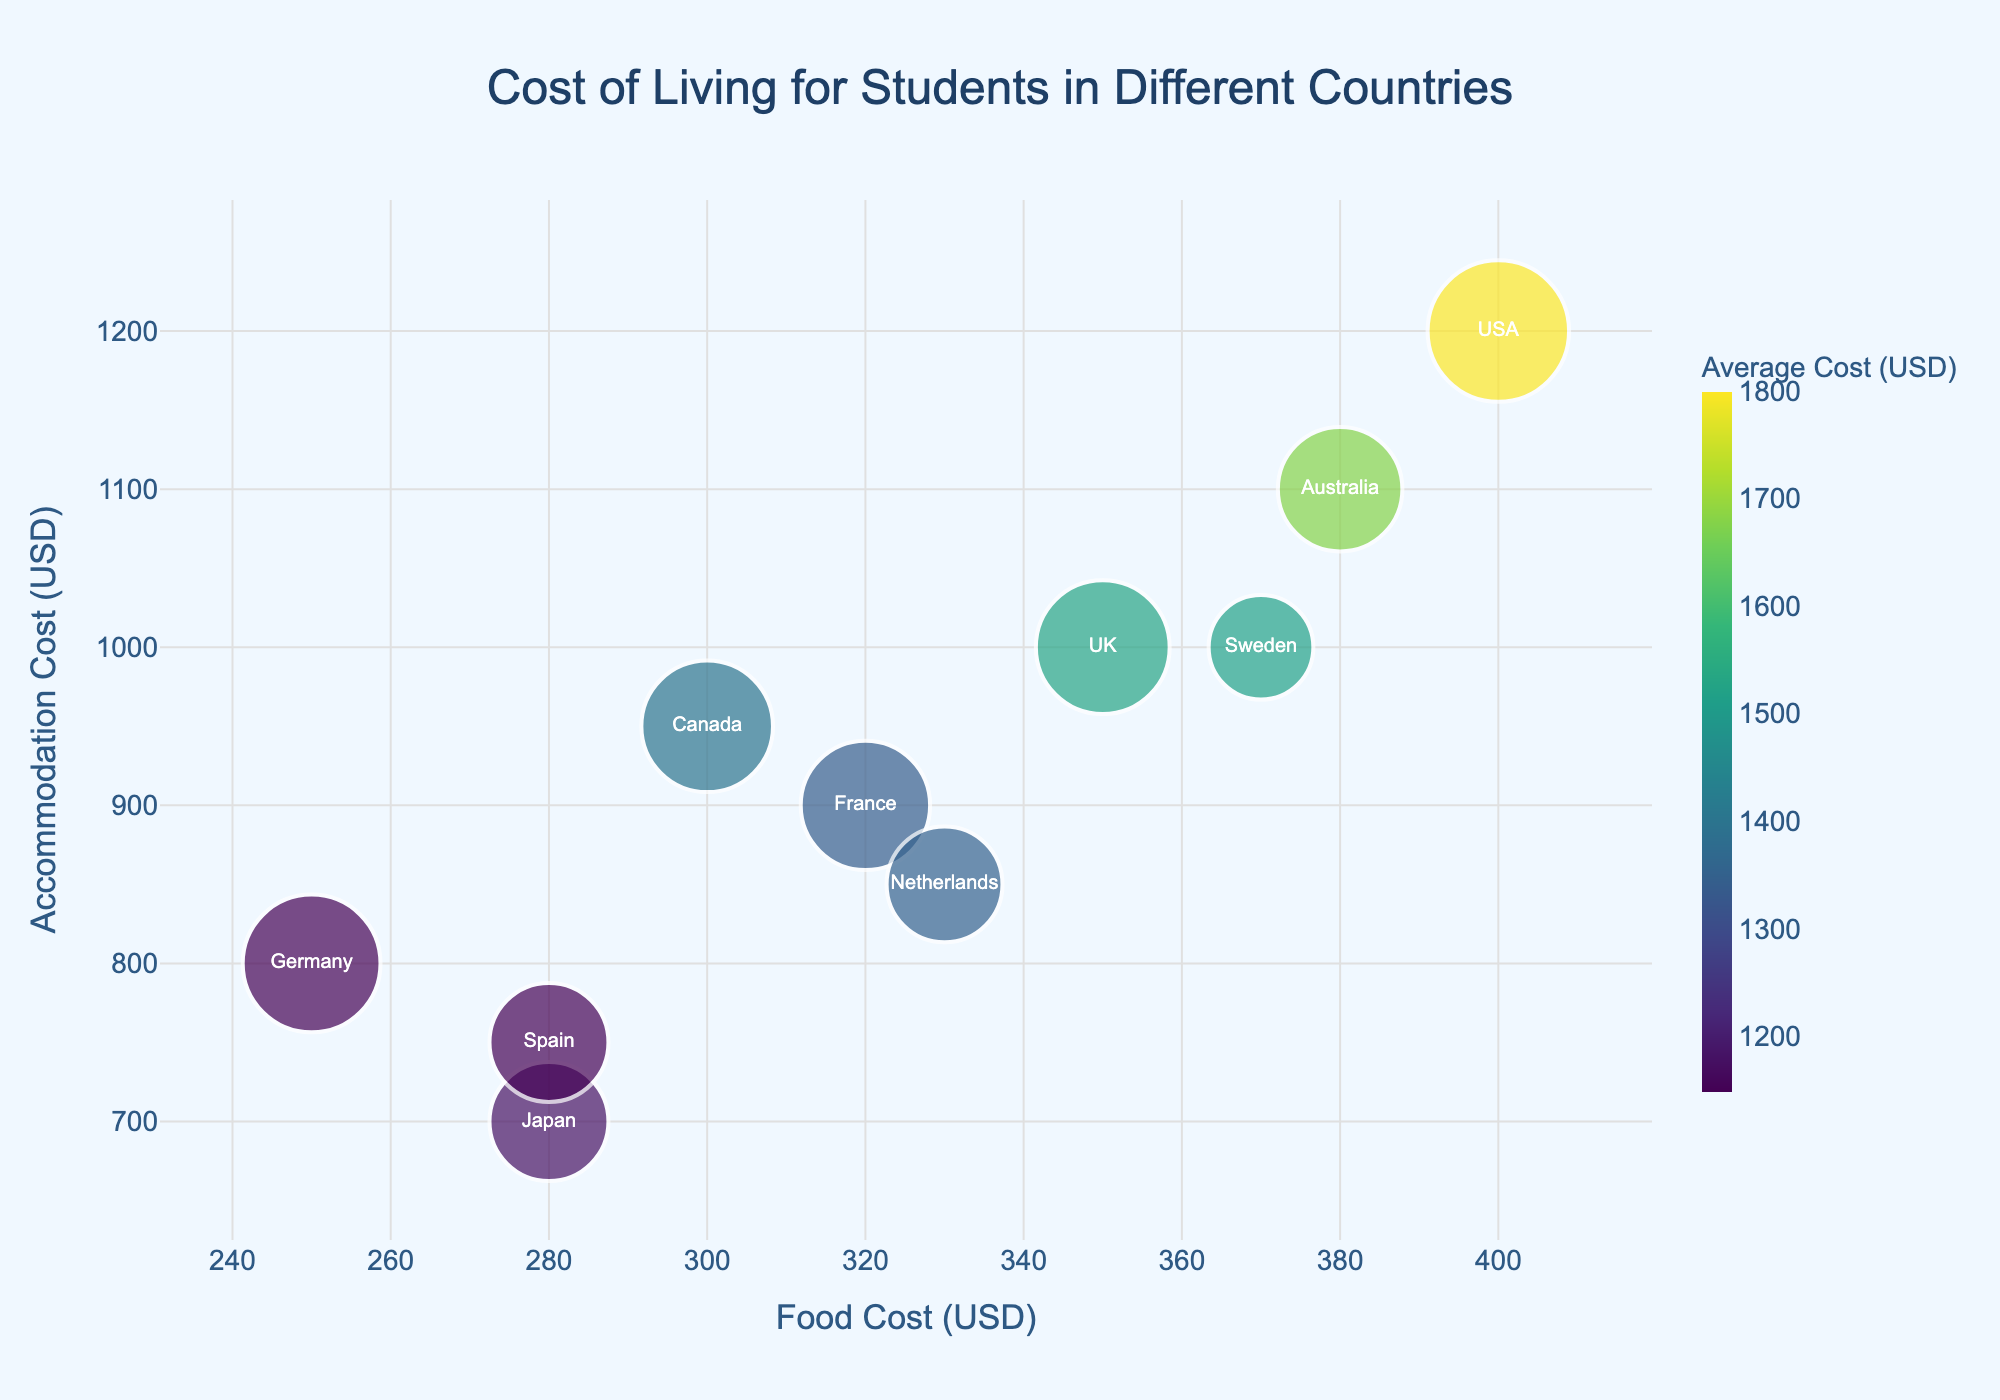What is the title of the figure? The title is displayed prominently at the top center of the figure. It reads "Cost of Living for Students in Different Countries."
Answer: Cost of Living for Students in Different Countries Which country has the highest accommodation cost? By looking at the y-axis representing Accommodation Cost, the bubble placed at the highest position indicates the country with the highest accommodation cost. The USA has the highest value on the y-axis.
Answer: USA How many countries are displayed in the figure? Each bubble in the figure represents a different country. Counting the bubbles gives the total number of countries. There are 10 bubbles.
Answer: 10 Which country has the lowest average cost of living for students? The color intensity of the bubbles represents the average cost of living, with deeper colors indicating higher costs. The palest bubble, which represents Germany, has the lowest average cost.
Answer: Germany What is the food cost for students in Japan? The x-axis represents the Food Cost. The bubble for Japan is located at an x-coordinate of 280, indicating a food cost of 280 USD.
Answer: 280 USD Which two countries have the same average cost of living for students? Comparing the color hues of the bubbles reveals that Germany and Spain share the same average cost, as both have the same color intensity.
Answer: Germany and Spain If a student has a budget of 1500 USD for accommodation and food, which countries fall within this budget? Adding the Food Cost (x-axis) and Accommodation Cost (y-axis) for each country, we look for countries where their sum is less than or equal to 1500 USD. Germany (800+250=1050) and Spain (750+280=1030) both fall within this budget.
Answer: Germany, Spain What is the total number of students represented by the USA and the UK combined? Summing up the Number of Students indicated by the bubble sizes: USA has 10,000 students, and UK has 8,000 students. The total is 10,000 + 8,000 = 18,000.
Answer: 18,000 In which country do entertainment costs the most for students? Identifying the bubble where the y-coordinate (accommodation costs) and x-coordinate (food costs) don’t necessitate high costs, but the bubble is still highly colored. Specifically focusing on entertainment cost data, the USA and Australia both have high values of 200 USD.
Answer: USA, Australia How does the accommodation cost in Canada compare to that in Australia? The y-axis values provide the accommodation cost: Canada is at 950 USD, and Australia is at 1100 USD. Canada’s accommodation cost is lower than Australia's.
Answer: Canada's cost is lower 